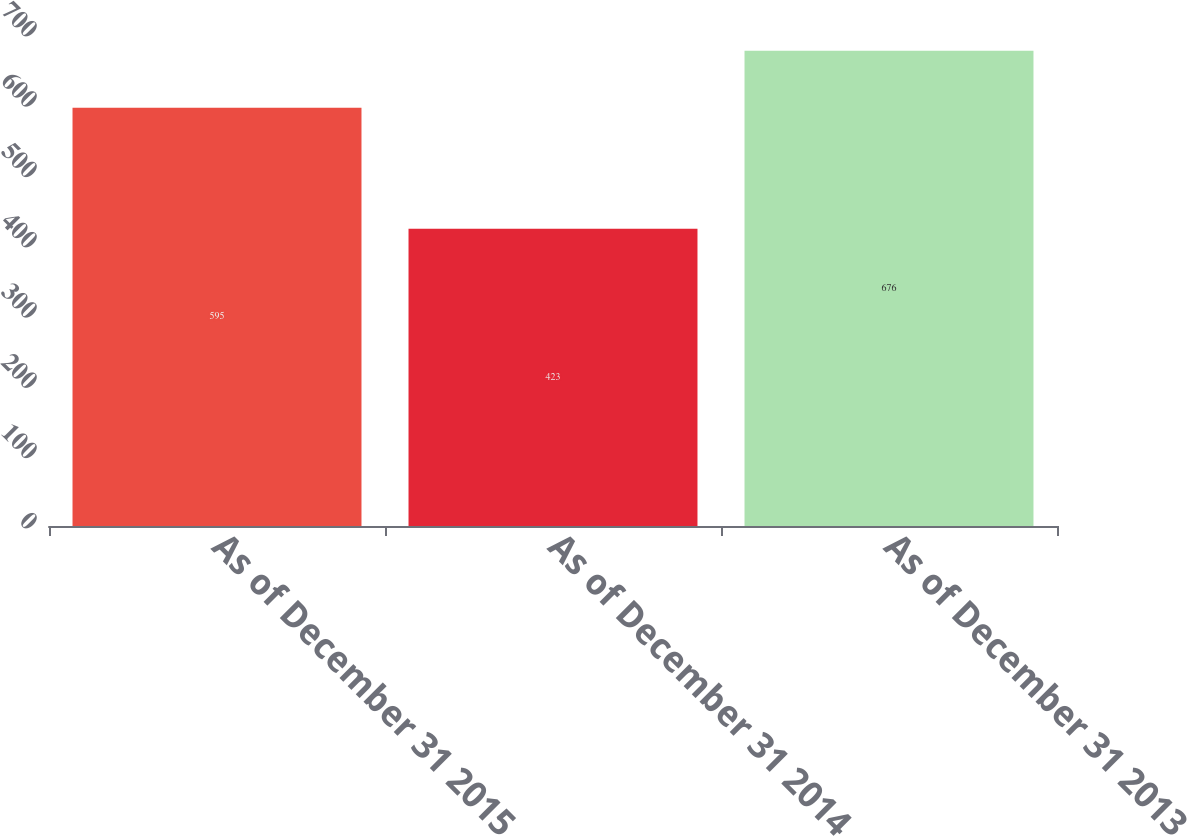<chart> <loc_0><loc_0><loc_500><loc_500><bar_chart><fcel>As of December 31 2015<fcel>As of December 31 2014<fcel>As of December 31 2013<nl><fcel>595<fcel>423<fcel>676<nl></chart> 